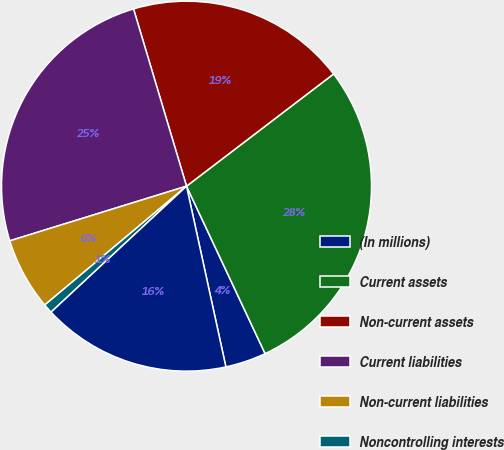Convert chart to OTSL. <chart><loc_0><loc_0><loc_500><loc_500><pie_chart><fcel>(In millions)<fcel>Current assets<fcel>Non-current assets<fcel>Current liabilities<fcel>Non-current liabilities<fcel>Noncontrolling interests<fcel>Net assets<nl><fcel>3.57%<fcel>28.39%<fcel>19.25%<fcel>25.15%<fcel>6.33%<fcel>0.82%<fcel>16.49%<nl></chart> 